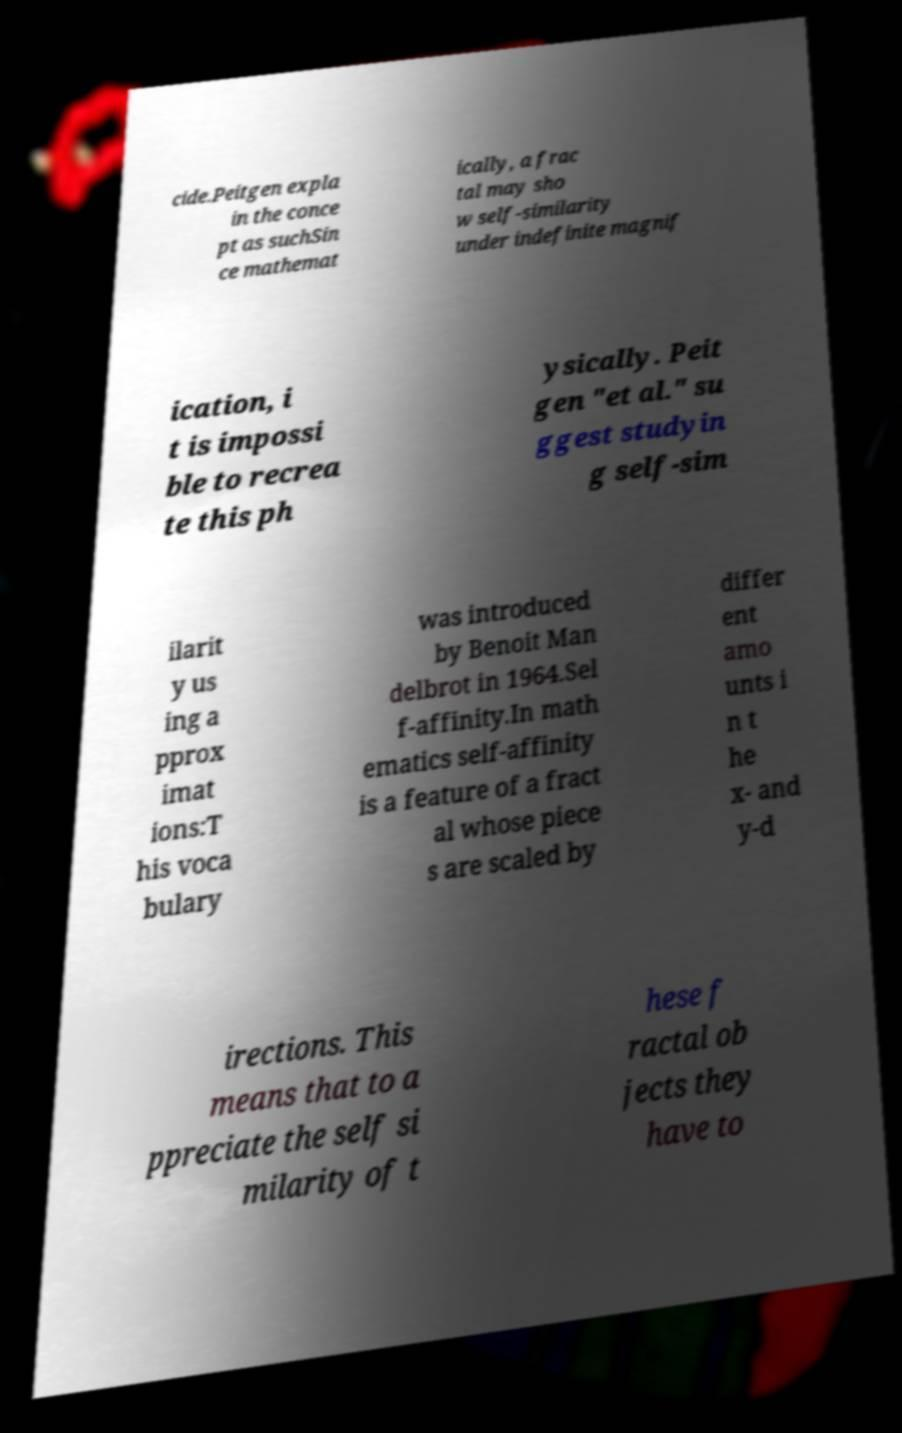Please read and relay the text visible in this image. What does it say? cide.Peitgen expla in the conce pt as suchSin ce mathemat ically, a frac tal may sho w self-similarity under indefinite magnif ication, i t is impossi ble to recrea te this ph ysically. Peit gen "et al." su ggest studyin g self-sim ilarit y us ing a pprox imat ions:T his voca bulary was introduced by Benoit Man delbrot in 1964.Sel f-affinity.In math ematics self-affinity is a feature of a fract al whose piece s are scaled by differ ent amo unts i n t he x- and y-d irections. This means that to a ppreciate the self si milarity of t hese f ractal ob jects they have to 